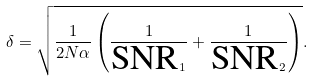Convert formula to latex. <formula><loc_0><loc_0><loc_500><loc_500>\delta = \sqrt { \frac { 1 } { 2 N \alpha } \left ( \frac { 1 } { \text {SNR} _ { 1 } } + \frac { 1 } { \text {SNR} _ { 2 } } \right ) } .</formula> 